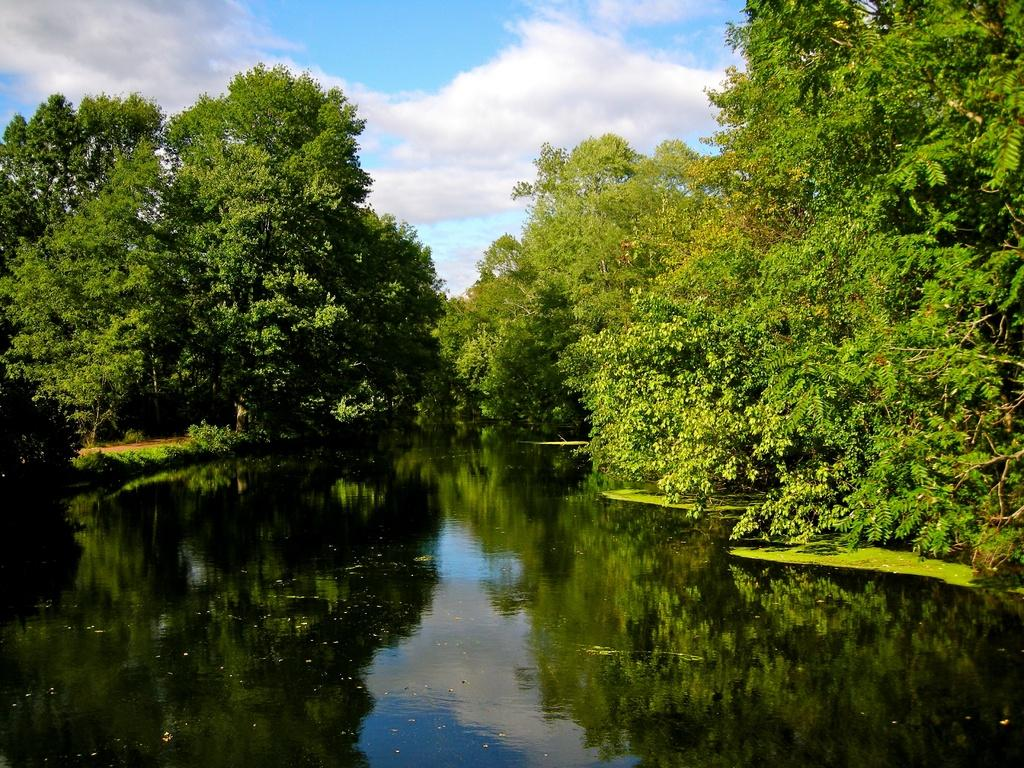What is present at the bottom side of the image? There is water at the bottom side of the image. What can be seen in the center of the image? There is greenery in the center of the image. Where is the secretary located in the image? There is no secretary present in the image. What type of army can be seen in the image? There is no army present in the image. 